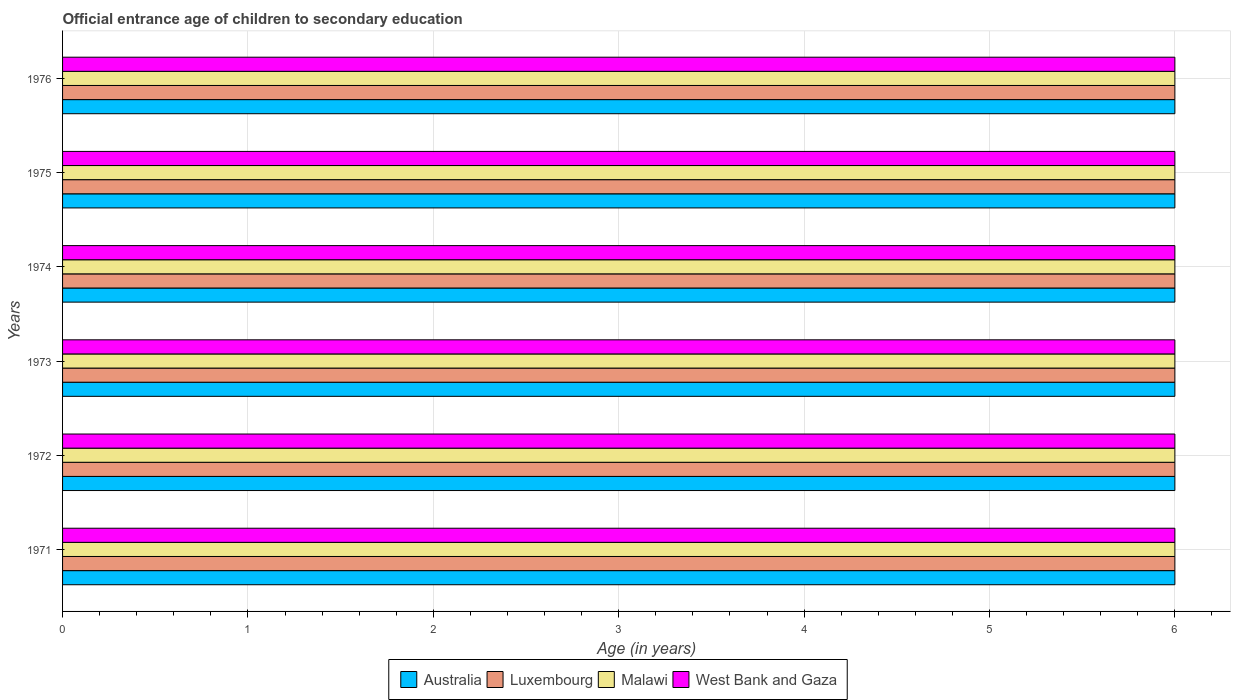Are the number of bars per tick equal to the number of legend labels?
Give a very brief answer. Yes. Are the number of bars on each tick of the Y-axis equal?
Make the answer very short. Yes. In how many cases, is the number of bars for a given year not equal to the number of legend labels?
Offer a terse response. 0. What is the total secondary school starting age of children in Australia in the graph?
Offer a very short reply. 36. What is the difference between the secondary school starting age of children in Australia in 1972 and that in 1973?
Offer a very short reply. 0. What is the difference between the secondary school starting age of children in Malawi in 1975 and the secondary school starting age of children in West Bank and Gaza in 1974?
Ensure brevity in your answer.  0. What is the average secondary school starting age of children in Luxembourg per year?
Offer a very short reply. 6. In the year 1975, what is the difference between the secondary school starting age of children in Malawi and secondary school starting age of children in Luxembourg?
Your answer should be compact. 0. In how many years, is the secondary school starting age of children in Australia greater than 5 years?
Provide a short and direct response. 6. What is the ratio of the secondary school starting age of children in Malawi in 1971 to that in 1973?
Ensure brevity in your answer.  1. What is the difference between the highest and the second highest secondary school starting age of children in Luxembourg?
Your answer should be compact. 0. What is the difference between the highest and the lowest secondary school starting age of children in Australia?
Make the answer very short. 0. What does the 1st bar from the top in 1976 represents?
Give a very brief answer. West Bank and Gaza. What does the 1st bar from the bottom in 1971 represents?
Offer a terse response. Australia. Is it the case that in every year, the sum of the secondary school starting age of children in West Bank and Gaza and secondary school starting age of children in Luxembourg is greater than the secondary school starting age of children in Australia?
Give a very brief answer. Yes. How many bars are there?
Provide a short and direct response. 24. Are all the bars in the graph horizontal?
Your answer should be compact. Yes. What is the difference between two consecutive major ticks on the X-axis?
Your response must be concise. 1. Are the values on the major ticks of X-axis written in scientific E-notation?
Provide a succinct answer. No. Where does the legend appear in the graph?
Provide a short and direct response. Bottom center. How many legend labels are there?
Make the answer very short. 4. How are the legend labels stacked?
Offer a terse response. Horizontal. What is the title of the graph?
Offer a terse response. Official entrance age of children to secondary education. What is the label or title of the X-axis?
Provide a succinct answer. Age (in years). What is the Age (in years) in Australia in 1971?
Your answer should be very brief. 6. What is the Age (in years) in West Bank and Gaza in 1971?
Your answer should be compact. 6. What is the Age (in years) of Australia in 1972?
Give a very brief answer. 6. What is the Age (in years) in Luxembourg in 1972?
Make the answer very short. 6. What is the Age (in years) in Luxembourg in 1974?
Ensure brevity in your answer.  6. What is the Age (in years) in Malawi in 1974?
Make the answer very short. 6. What is the Age (in years) of West Bank and Gaza in 1974?
Your response must be concise. 6. What is the Age (in years) in Malawi in 1975?
Ensure brevity in your answer.  6. What is the Age (in years) in West Bank and Gaza in 1975?
Ensure brevity in your answer.  6. What is the Age (in years) in West Bank and Gaza in 1976?
Your response must be concise. 6. Across all years, what is the maximum Age (in years) in Australia?
Offer a very short reply. 6. Across all years, what is the maximum Age (in years) of Luxembourg?
Your response must be concise. 6. Across all years, what is the maximum Age (in years) in Malawi?
Your answer should be very brief. 6. Across all years, what is the minimum Age (in years) in Australia?
Your answer should be very brief. 6. Across all years, what is the minimum Age (in years) of Malawi?
Give a very brief answer. 6. What is the total Age (in years) in Australia in the graph?
Your answer should be compact. 36. What is the total Age (in years) in West Bank and Gaza in the graph?
Offer a very short reply. 36. What is the difference between the Age (in years) in Australia in 1971 and that in 1972?
Your answer should be very brief. 0. What is the difference between the Age (in years) of West Bank and Gaza in 1971 and that in 1972?
Ensure brevity in your answer.  0. What is the difference between the Age (in years) in Australia in 1971 and that in 1973?
Your response must be concise. 0. What is the difference between the Age (in years) of Luxembourg in 1971 and that in 1973?
Provide a short and direct response. 0. What is the difference between the Age (in years) of Malawi in 1971 and that in 1973?
Offer a terse response. 0. What is the difference between the Age (in years) of West Bank and Gaza in 1971 and that in 1973?
Provide a short and direct response. 0. What is the difference between the Age (in years) in Australia in 1971 and that in 1975?
Your response must be concise. 0. What is the difference between the Age (in years) of Luxembourg in 1971 and that in 1975?
Give a very brief answer. 0. What is the difference between the Age (in years) in Malawi in 1971 and that in 1975?
Give a very brief answer. 0. What is the difference between the Age (in years) in West Bank and Gaza in 1971 and that in 1975?
Provide a succinct answer. 0. What is the difference between the Age (in years) in Australia in 1971 and that in 1976?
Your answer should be compact. 0. What is the difference between the Age (in years) in Luxembourg in 1971 and that in 1976?
Offer a terse response. 0. What is the difference between the Age (in years) of West Bank and Gaza in 1971 and that in 1976?
Ensure brevity in your answer.  0. What is the difference between the Age (in years) in Australia in 1972 and that in 1973?
Make the answer very short. 0. What is the difference between the Age (in years) of West Bank and Gaza in 1972 and that in 1973?
Your answer should be compact. 0. What is the difference between the Age (in years) in Australia in 1972 and that in 1974?
Keep it short and to the point. 0. What is the difference between the Age (in years) of Australia in 1972 and that in 1975?
Your answer should be compact. 0. What is the difference between the Age (in years) of Luxembourg in 1972 and that in 1975?
Your response must be concise. 0. What is the difference between the Age (in years) of Malawi in 1972 and that in 1975?
Your response must be concise. 0. What is the difference between the Age (in years) in West Bank and Gaza in 1972 and that in 1975?
Offer a very short reply. 0. What is the difference between the Age (in years) of Australia in 1972 and that in 1976?
Ensure brevity in your answer.  0. What is the difference between the Age (in years) in Luxembourg in 1972 and that in 1976?
Provide a short and direct response. 0. What is the difference between the Age (in years) of West Bank and Gaza in 1972 and that in 1976?
Offer a very short reply. 0. What is the difference between the Age (in years) of Luxembourg in 1973 and that in 1974?
Offer a very short reply. 0. What is the difference between the Age (in years) of Malawi in 1973 and that in 1974?
Keep it short and to the point. 0. What is the difference between the Age (in years) in Australia in 1973 and that in 1975?
Provide a short and direct response. 0. What is the difference between the Age (in years) of Luxembourg in 1973 and that in 1975?
Provide a succinct answer. 0. What is the difference between the Age (in years) of Luxembourg in 1973 and that in 1976?
Give a very brief answer. 0. What is the difference between the Age (in years) in West Bank and Gaza in 1973 and that in 1976?
Provide a short and direct response. 0. What is the difference between the Age (in years) in Malawi in 1974 and that in 1975?
Offer a very short reply. 0. What is the difference between the Age (in years) of West Bank and Gaza in 1974 and that in 1975?
Keep it short and to the point. 0. What is the difference between the Age (in years) in Malawi in 1974 and that in 1976?
Offer a terse response. 0. What is the difference between the Age (in years) of West Bank and Gaza in 1974 and that in 1976?
Ensure brevity in your answer.  0. What is the difference between the Age (in years) of Australia in 1975 and that in 1976?
Provide a short and direct response. 0. What is the difference between the Age (in years) of Malawi in 1975 and that in 1976?
Give a very brief answer. 0. What is the difference between the Age (in years) of West Bank and Gaza in 1975 and that in 1976?
Your response must be concise. 0. What is the difference between the Age (in years) in Australia in 1971 and the Age (in years) in Luxembourg in 1972?
Provide a succinct answer. 0. What is the difference between the Age (in years) of Luxembourg in 1971 and the Age (in years) of Malawi in 1972?
Provide a short and direct response. 0. What is the difference between the Age (in years) in Malawi in 1971 and the Age (in years) in West Bank and Gaza in 1972?
Keep it short and to the point. 0. What is the difference between the Age (in years) in Australia in 1971 and the Age (in years) in Luxembourg in 1973?
Your answer should be compact. 0. What is the difference between the Age (in years) in Australia in 1971 and the Age (in years) in West Bank and Gaza in 1973?
Your answer should be very brief. 0. What is the difference between the Age (in years) of Luxembourg in 1971 and the Age (in years) of Malawi in 1973?
Your answer should be very brief. 0. What is the difference between the Age (in years) in Malawi in 1971 and the Age (in years) in West Bank and Gaza in 1973?
Make the answer very short. 0. What is the difference between the Age (in years) of Australia in 1971 and the Age (in years) of Luxembourg in 1974?
Keep it short and to the point. 0. What is the difference between the Age (in years) in Australia in 1971 and the Age (in years) in Malawi in 1974?
Give a very brief answer. 0. What is the difference between the Age (in years) in Australia in 1971 and the Age (in years) in West Bank and Gaza in 1974?
Provide a succinct answer. 0. What is the difference between the Age (in years) of Luxembourg in 1971 and the Age (in years) of West Bank and Gaza in 1974?
Make the answer very short. 0. What is the difference between the Age (in years) of Malawi in 1971 and the Age (in years) of West Bank and Gaza in 1974?
Offer a terse response. 0. What is the difference between the Age (in years) of Australia in 1971 and the Age (in years) of Luxembourg in 1975?
Your answer should be very brief. 0. What is the difference between the Age (in years) of Australia in 1971 and the Age (in years) of Malawi in 1975?
Ensure brevity in your answer.  0. What is the difference between the Age (in years) of Luxembourg in 1971 and the Age (in years) of Malawi in 1975?
Keep it short and to the point. 0. What is the difference between the Age (in years) in Luxembourg in 1971 and the Age (in years) in West Bank and Gaza in 1975?
Offer a terse response. 0. What is the difference between the Age (in years) of Australia in 1971 and the Age (in years) of West Bank and Gaza in 1976?
Offer a terse response. 0. What is the difference between the Age (in years) of Luxembourg in 1971 and the Age (in years) of Malawi in 1976?
Make the answer very short. 0. What is the difference between the Age (in years) in Luxembourg in 1971 and the Age (in years) in West Bank and Gaza in 1976?
Give a very brief answer. 0. What is the difference between the Age (in years) of Australia in 1972 and the Age (in years) of Luxembourg in 1973?
Give a very brief answer. 0. What is the difference between the Age (in years) in Luxembourg in 1972 and the Age (in years) in Malawi in 1973?
Offer a terse response. 0. What is the difference between the Age (in years) of Luxembourg in 1972 and the Age (in years) of West Bank and Gaza in 1973?
Your answer should be compact. 0. What is the difference between the Age (in years) in Malawi in 1972 and the Age (in years) in West Bank and Gaza in 1973?
Your response must be concise. 0. What is the difference between the Age (in years) in Australia in 1972 and the Age (in years) in Luxembourg in 1974?
Provide a short and direct response. 0. What is the difference between the Age (in years) in Luxembourg in 1972 and the Age (in years) in West Bank and Gaza in 1974?
Offer a terse response. 0. What is the difference between the Age (in years) in Australia in 1972 and the Age (in years) in Malawi in 1975?
Your answer should be compact. 0. What is the difference between the Age (in years) in Luxembourg in 1972 and the Age (in years) in Malawi in 1975?
Your answer should be very brief. 0. What is the difference between the Age (in years) in Luxembourg in 1972 and the Age (in years) in West Bank and Gaza in 1975?
Your response must be concise. 0. What is the difference between the Age (in years) in Australia in 1972 and the Age (in years) in Luxembourg in 1976?
Offer a terse response. 0. What is the difference between the Age (in years) in Australia in 1972 and the Age (in years) in Malawi in 1976?
Your answer should be compact. 0. What is the difference between the Age (in years) in Australia in 1972 and the Age (in years) in West Bank and Gaza in 1976?
Keep it short and to the point. 0. What is the difference between the Age (in years) in Luxembourg in 1972 and the Age (in years) in Malawi in 1976?
Provide a short and direct response. 0. What is the difference between the Age (in years) in Luxembourg in 1972 and the Age (in years) in West Bank and Gaza in 1976?
Give a very brief answer. 0. What is the difference between the Age (in years) of Malawi in 1972 and the Age (in years) of West Bank and Gaza in 1976?
Provide a short and direct response. 0. What is the difference between the Age (in years) in Australia in 1973 and the Age (in years) in Malawi in 1974?
Provide a succinct answer. 0. What is the difference between the Age (in years) of Luxembourg in 1973 and the Age (in years) of Malawi in 1974?
Provide a succinct answer. 0. What is the difference between the Age (in years) in Luxembourg in 1973 and the Age (in years) in West Bank and Gaza in 1974?
Ensure brevity in your answer.  0. What is the difference between the Age (in years) of Australia in 1973 and the Age (in years) of Luxembourg in 1975?
Your response must be concise. 0. What is the difference between the Age (in years) in Australia in 1973 and the Age (in years) in West Bank and Gaza in 1975?
Ensure brevity in your answer.  0. What is the difference between the Age (in years) in Luxembourg in 1973 and the Age (in years) in West Bank and Gaza in 1975?
Your response must be concise. 0. What is the difference between the Age (in years) in Malawi in 1973 and the Age (in years) in West Bank and Gaza in 1975?
Provide a succinct answer. 0. What is the difference between the Age (in years) of Australia in 1973 and the Age (in years) of West Bank and Gaza in 1976?
Offer a very short reply. 0. What is the difference between the Age (in years) in Luxembourg in 1973 and the Age (in years) in Malawi in 1976?
Your answer should be very brief. 0. What is the difference between the Age (in years) of Luxembourg in 1973 and the Age (in years) of West Bank and Gaza in 1976?
Keep it short and to the point. 0. What is the difference between the Age (in years) of Australia in 1974 and the Age (in years) of Luxembourg in 1975?
Your response must be concise. 0. What is the difference between the Age (in years) in Australia in 1974 and the Age (in years) in West Bank and Gaza in 1975?
Your response must be concise. 0. What is the difference between the Age (in years) of Luxembourg in 1974 and the Age (in years) of Malawi in 1975?
Give a very brief answer. 0. What is the difference between the Age (in years) in Luxembourg in 1974 and the Age (in years) in West Bank and Gaza in 1975?
Provide a succinct answer. 0. What is the difference between the Age (in years) in Australia in 1974 and the Age (in years) in West Bank and Gaza in 1976?
Give a very brief answer. 0. What is the difference between the Age (in years) of Luxembourg in 1974 and the Age (in years) of West Bank and Gaza in 1976?
Provide a succinct answer. 0. What is the difference between the Age (in years) in Australia in 1975 and the Age (in years) in Luxembourg in 1976?
Give a very brief answer. 0. What is the difference between the Age (in years) in Luxembourg in 1975 and the Age (in years) in West Bank and Gaza in 1976?
Your answer should be compact. 0. What is the average Age (in years) of Malawi per year?
Your answer should be compact. 6. In the year 1971, what is the difference between the Age (in years) of Australia and Age (in years) of Luxembourg?
Offer a very short reply. 0. In the year 1971, what is the difference between the Age (in years) in Australia and Age (in years) in West Bank and Gaza?
Provide a succinct answer. 0. In the year 1971, what is the difference between the Age (in years) in Luxembourg and Age (in years) in Malawi?
Offer a terse response. 0. In the year 1971, what is the difference between the Age (in years) of Luxembourg and Age (in years) of West Bank and Gaza?
Your answer should be very brief. 0. In the year 1971, what is the difference between the Age (in years) in Malawi and Age (in years) in West Bank and Gaza?
Keep it short and to the point. 0. In the year 1972, what is the difference between the Age (in years) in Australia and Age (in years) in Malawi?
Your answer should be compact. 0. In the year 1972, what is the difference between the Age (in years) of Australia and Age (in years) of West Bank and Gaza?
Your response must be concise. 0. In the year 1972, what is the difference between the Age (in years) in Luxembourg and Age (in years) in Malawi?
Offer a terse response. 0. In the year 1972, what is the difference between the Age (in years) of Malawi and Age (in years) of West Bank and Gaza?
Your response must be concise. 0. In the year 1973, what is the difference between the Age (in years) of Australia and Age (in years) of Luxembourg?
Your response must be concise. 0. In the year 1973, what is the difference between the Age (in years) of Australia and Age (in years) of Malawi?
Ensure brevity in your answer.  0. In the year 1973, what is the difference between the Age (in years) in Australia and Age (in years) in West Bank and Gaza?
Provide a succinct answer. 0. In the year 1973, what is the difference between the Age (in years) in Luxembourg and Age (in years) in Malawi?
Keep it short and to the point. 0. In the year 1973, what is the difference between the Age (in years) in Luxembourg and Age (in years) in West Bank and Gaza?
Offer a very short reply. 0. In the year 1973, what is the difference between the Age (in years) in Malawi and Age (in years) in West Bank and Gaza?
Your answer should be very brief. 0. In the year 1974, what is the difference between the Age (in years) in Australia and Age (in years) in Luxembourg?
Provide a short and direct response. 0. In the year 1974, what is the difference between the Age (in years) in Australia and Age (in years) in Malawi?
Your response must be concise. 0. In the year 1974, what is the difference between the Age (in years) in Luxembourg and Age (in years) in Malawi?
Provide a short and direct response. 0. In the year 1974, what is the difference between the Age (in years) of Luxembourg and Age (in years) of West Bank and Gaza?
Give a very brief answer. 0. In the year 1975, what is the difference between the Age (in years) of Australia and Age (in years) of Luxembourg?
Offer a very short reply. 0. In the year 1975, what is the difference between the Age (in years) in Luxembourg and Age (in years) in Malawi?
Provide a succinct answer. 0. In the year 1975, what is the difference between the Age (in years) of Malawi and Age (in years) of West Bank and Gaza?
Ensure brevity in your answer.  0. In the year 1976, what is the difference between the Age (in years) of Australia and Age (in years) of Luxembourg?
Make the answer very short. 0. In the year 1976, what is the difference between the Age (in years) of Australia and Age (in years) of Malawi?
Make the answer very short. 0. In the year 1976, what is the difference between the Age (in years) of Australia and Age (in years) of West Bank and Gaza?
Keep it short and to the point. 0. In the year 1976, what is the difference between the Age (in years) of Luxembourg and Age (in years) of West Bank and Gaza?
Your answer should be compact. 0. What is the ratio of the Age (in years) in Australia in 1971 to that in 1972?
Provide a short and direct response. 1. What is the ratio of the Age (in years) in Luxembourg in 1971 to that in 1972?
Provide a succinct answer. 1. What is the ratio of the Age (in years) in Australia in 1971 to that in 1973?
Give a very brief answer. 1. What is the ratio of the Age (in years) in West Bank and Gaza in 1971 to that in 1974?
Provide a short and direct response. 1. What is the ratio of the Age (in years) of Australia in 1971 to that in 1976?
Provide a short and direct response. 1. What is the ratio of the Age (in years) in Luxembourg in 1971 to that in 1976?
Your response must be concise. 1. What is the ratio of the Age (in years) in Australia in 1972 to that in 1973?
Provide a succinct answer. 1. What is the ratio of the Age (in years) of Australia in 1972 to that in 1974?
Give a very brief answer. 1. What is the ratio of the Age (in years) in Malawi in 1972 to that in 1974?
Your response must be concise. 1. What is the ratio of the Age (in years) of West Bank and Gaza in 1972 to that in 1974?
Your answer should be very brief. 1. What is the ratio of the Age (in years) of Australia in 1972 to that in 1975?
Provide a short and direct response. 1. What is the ratio of the Age (in years) of Luxembourg in 1972 to that in 1975?
Provide a succinct answer. 1. What is the ratio of the Age (in years) of West Bank and Gaza in 1972 to that in 1975?
Ensure brevity in your answer.  1. What is the ratio of the Age (in years) of Australia in 1972 to that in 1976?
Keep it short and to the point. 1. What is the ratio of the Age (in years) of Luxembourg in 1972 to that in 1976?
Give a very brief answer. 1. What is the ratio of the Age (in years) of Malawi in 1972 to that in 1976?
Your response must be concise. 1. What is the ratio of the Age (in years) of West Bank and Gaza in 1973 to that in 1975?
Your answer should be compact. 1. What is the ratio of the Age (in years) of Australia in 1973 to that in 1976?
Your answer should be very brief. 1. What is the ratio of the Age (in years) of Luxembourg in 1974 to that in 1975?
Your answer should be compact. 1. What is the ratio of the Age (in years) of Malawi in 1974 to that in 1975?
Give a very brief answer. 1. What is the ratio of the Age (in years) of Australia in 1974 to that in 1976?
Give a very brief answer. 1. What is the ratio of the Age (in years) in Luxembourg in 1974 to that in 1976?
Give a very brief answer. 1. What is the ratio of the Age (in years) of West Bank and Gaza in 1975 to that in 1976?
Keep it short and to the point. 1. What is the difference between the highest and the second highest Age (in years) in Malawi?
Provide a succinct answer. 0. What is the difference between the highest and the second highest Age (in years) in West Bank and Gaza?
Ensure brevity in your answer.  0. What is the difference between the highest and the lowest Age (in years) of Luxembourg?
Make the answer very short. 0. 